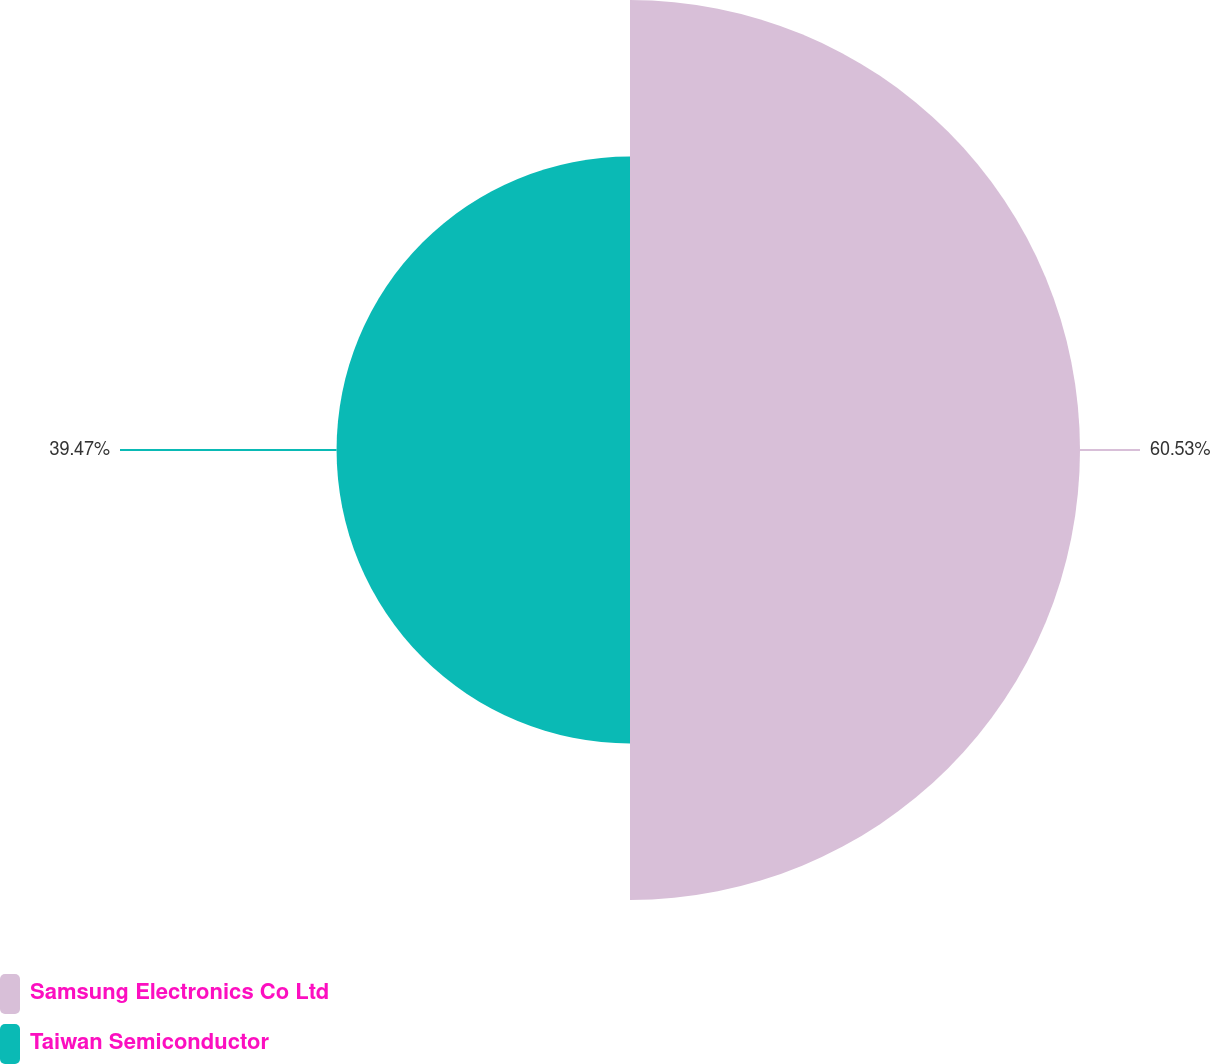Convert chart. <chart><loc_0><loc_0><loc_500><loc_500><pie_chart><fcel>Samsung Electronics Co Ltd<fcel>Taiwan Semiconductor<nl><fcel>60.53%<fcel>39.47%<nl></chart> 